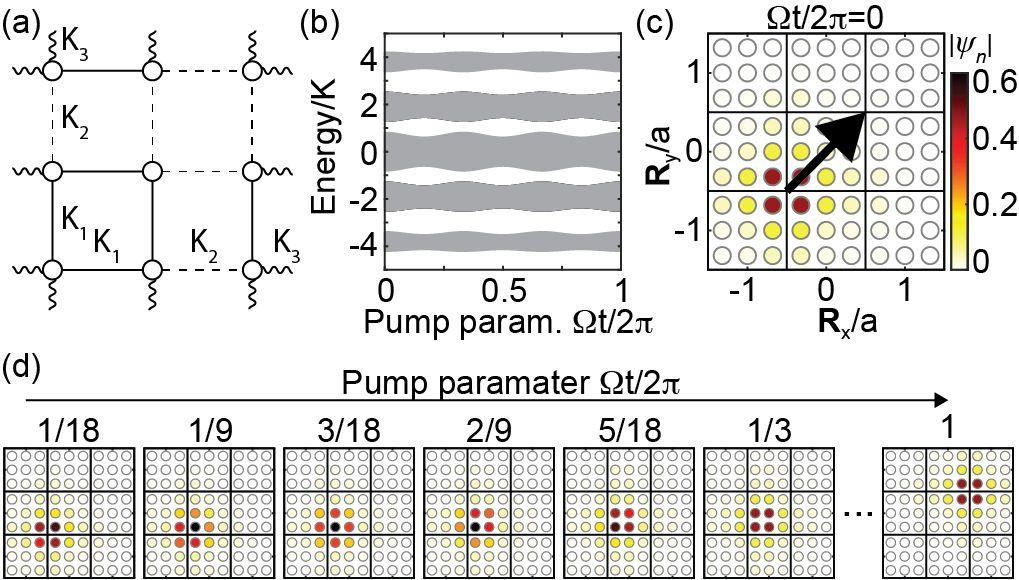Which subfigure indicates a relationship between energy and pump parameter? A. Subfigure (a) B. Subfigure (b) C. Subfigure (c) D. Subfigure (d) Subfigure (b) is the correct answer, as it clearly shows a graph where the vertical axis represents 'Energy/K' and the horizontal axis is labeled 'Pump param. \\(\Omega t/2\\pi\
o)'. This graph effectively maps how the energy levels vary with shifts in the pump parameter, providing a straightforward visual representation of their interdependence. This subfigure is crucial for those studying the impact of different pump parameters on the system's energy state. 